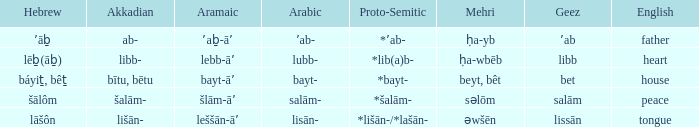If in arabic it is salām-, what is it in proto-semitic? *šalām-. 